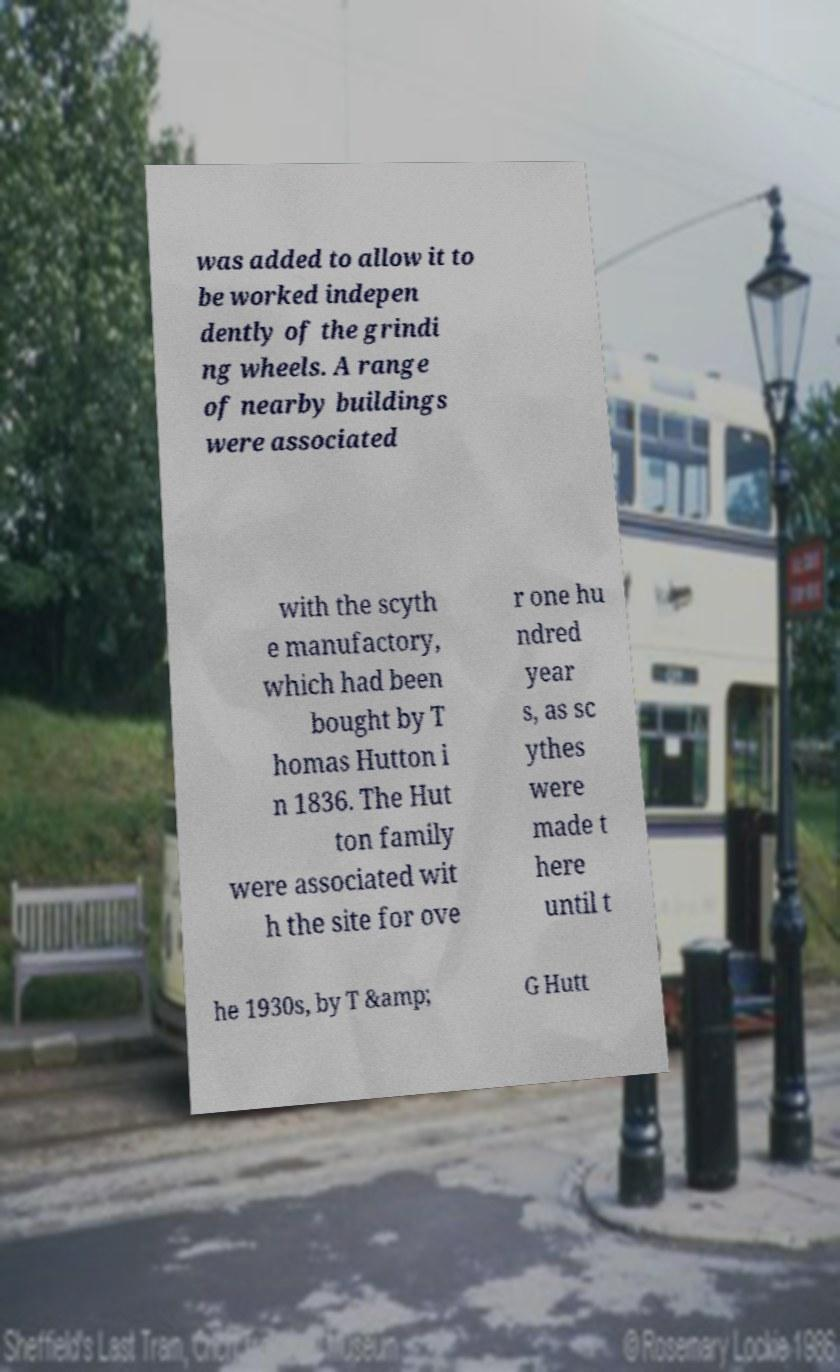Could you extract and type out the text from this image? was added to allow it to be worked indepen dently of the grindi ng wheels. A range of nearby buildings were associated with the scyth e manufactory, which had been bought by T homas Hutton i n 1836. The Hut ton family were associated wit h the site for ove r one hu ndred year s, as sc ythes were made t here until t he 1930s, by T &amp; G Hutt 